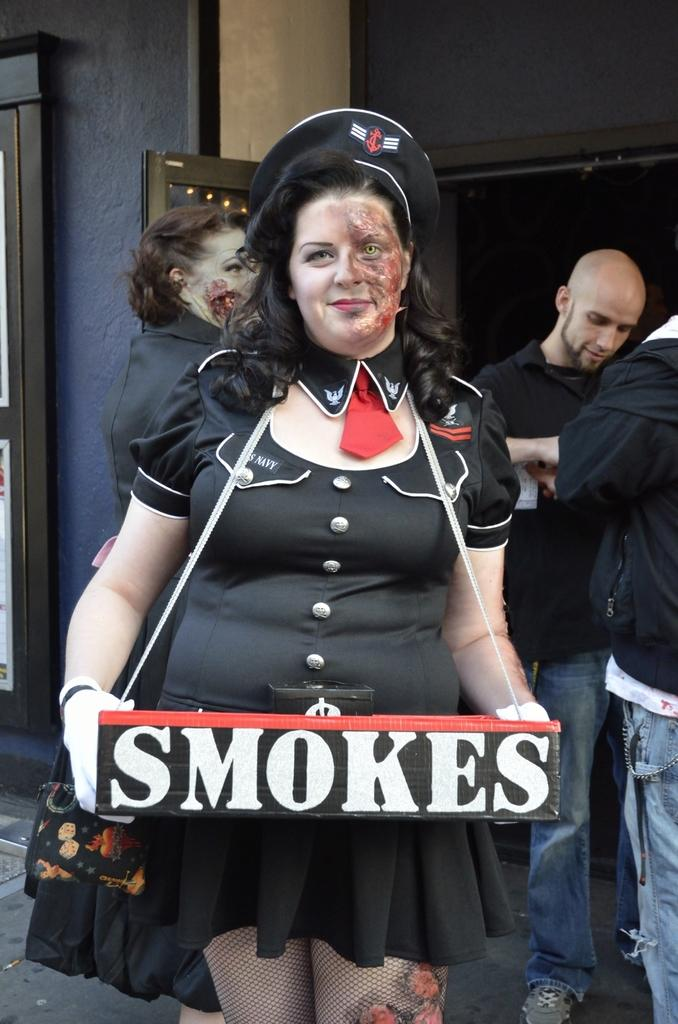How many people are in the image? There are people in the image, but the exact number is not specified. What is unique about the appearance of two of the people? Two of the people have paint on their faces. What is the lady holding in the image? The lady is holding a board with text on it. What can be seen in the background of the image? There is a wall visible in the image. Can you see any tigers or signs of destruction in the image? No, there are no tigers or signs of destruction present in the image. Are there any trains visible in the image? No, there are no trains visible in the image. 